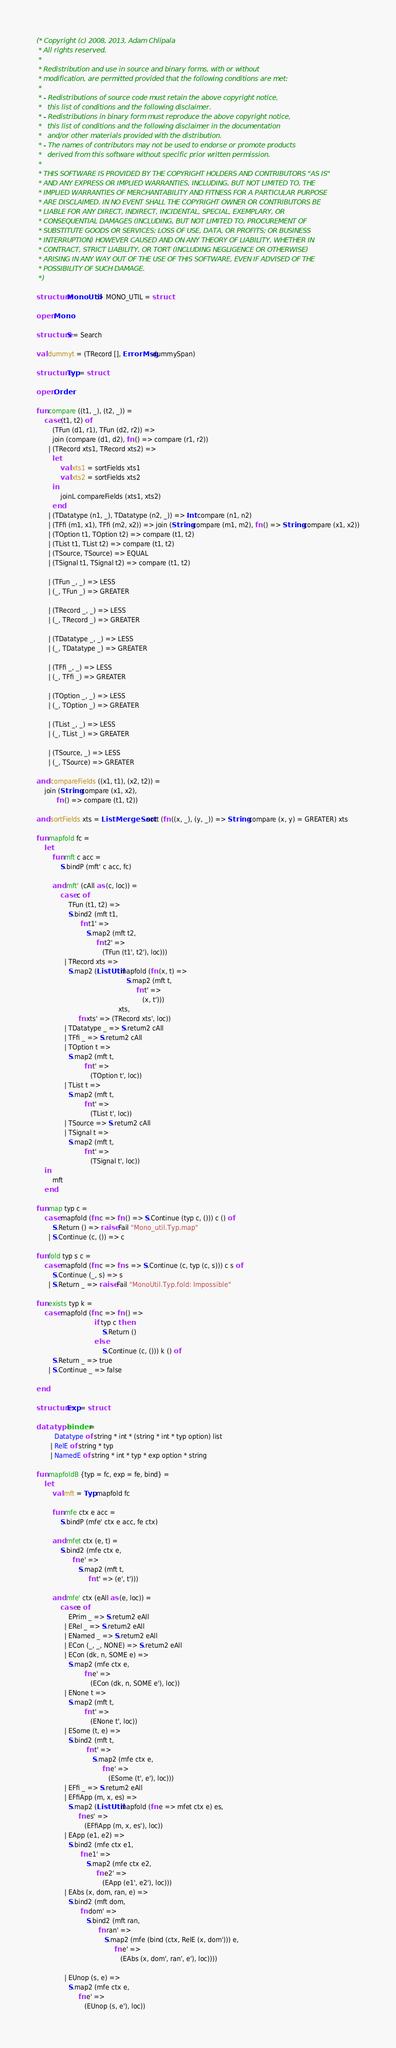Convert code to text. <code><loc_0><loc_0><loc_500><loc_500><_SML_>(* Copyright (c) 2008, 2013, Adam Chlipala
 * All rights reserved.
 *
 * Redistribution and use in source and binary forms, with or without
 * modification, are permitted provided that the following conditions are met:
 *
 * - Redistributions of source code must retain the above copyright notice,
 *   this list of conditions and the following disclaimer.
 * - Redistributions in binary form must reproduce the above copyright notice,
 *   this list of conditions and the following disclaimer in the documentation
 *   and/or other materials provided with the distribution.
 * - The names of contributors may not be used to endorse or promote products
 *   derived from this software without specific prior written permission.
 *
 * THIS SOFTWARE IS PROVIDED BY THE COPYRIGHT HOLDERS AND CONTRIBUTORS "AS IS"
 * AND ANY EXPRESS OR IMPLIED WARRANTIES, INCLUDING, BUT NOT LIMITED TO, THE
 * IMPLIED WARRANTIES OF MERCHANTABILITY AND FITNESS FOR A PARTICULAR PURPOSE
 * ARE DISCLAIMED. IN NO EVENT SHALL THE COPYRIGHT OWNER OR CONTRIBUTORS BE
 * LIABLE FOR ANY DIRECT, INDIRECT, INCIDENTAL, SPECIAL, EXEMPLARY, OR
 * CONSEQUENTIAL DAMAGES (INCLUDING, BUT NOT LIMITED TO, PROCUREMENT OF
 * SUBSTITUTE GOODS OR SERVICES; LOSS OF USE, DATA, OR PROFITS; OR BUSINESS
 * INTERRUPTION) HOWEVER CAUSED AND ON ANY THEORY OF LIABILITY, WHETHER IN
 * CONTRACT, STRICT LIABILITY, OR TORT (INCLUDING NEGLIGENCE OR OTHERWISE)
 * ARISING IN ANY WAY OUT OF THE USE OF THIS SOFTWARE, EVEN IF ADVISED OF THE
 * POSSIBILITY OF SUCH DAMAGE.
 *)

structure MonoUtil :> MONO_UTIL = struct

open Mono

structure S = Search

val dummyt = (TRecord [], ErrorMsg.dummySpan)

structure Typ = struct

open Order

fun compare ((t1, _), (t2, _)) =
    case (t1, t2) of
        (TFun (d1, r1), TFun (d2, r2)) =>
        join (compare (d1, d2), fn () => compare (r1, r2))
      | (TRecord xts1, TRecord xts2) =>
        let
            val xts1 = sortFields xts1
            val xts2 = sortFields xts2
        in
            joinL compareFields (xts1, xts2)
        end
      | (TDatatype (n1, _), TDatatype (n2, _)) => Int.compare (n1, n2)
      | (TFfi (m1, x1), TFfi (m2, x2)) => join (String.compare (m1, m2), fn () => String.compare (x1, x2))
      | (TOption t1, TOption t2) => compare (t1, t2)
      | (TList t1, TList t2) => compare (t1, t2)
      | (TSource, TSource) => EQUAL
      | (TSignal t1, TSignal t2) => compare (t1, t2)

      | (TFun _, _) => LESS
      | (_, TFun _) => GREATER

      | (TRecord _, _) => LESS
      | (_, TRecord _) => GREATER

      | (TDatatype _, _) => LESS
      | (_, TDatatype _) => GREATER

      | (TFfi _, _) => LESS
      | (_, TFfi _) => GREATER

      | (TOption _, _) => LESS
      | (_, TOption _) => GREATER

      | (TList _, _) => LESS
      | (_, TList _) => GREATER

      | (TSource, _) => LESS
      | (_, TSource) => GREATER

and compareFields ((x1, t1), (x2, t2)) =
    join (String.compare (x1, x2),
          fn () => compare (t1, t2))

and sortFields xts = ListMergeSort.sort (fn ((x, _), (y, _)) => String.compare (x, y) = GREATER) xts

fun mapfold fc =
    let
        fun mft c acc =
            S.bindP (mft' c acc, fc)

        and mft' (cAll as (c, loc)) =
            case c of
                TFun (t1, t2) =>
                S.bind2 (mft t1,
                      fn t1' =>
                         S.map2 (mft t2,
                              fn t2' =>
                                 (TFun (t1', t2'), loc)))
              | TRecord xts =>
                S.map2 (ListUtil.mapfold (fn (x, t) =>
                                             S.map2 (mft t,
                                                  fn t' =>
                                                     (x, t')))
                                         xts,
                     fn xts' => (TRecord xts', loc))
              | TDatatype _ => S.return2 cAll
              | TFfi _ => S.return2 cAll
              | TOption t =>
                S.map2 (mft t,
                        fn t' =>
                           (TOption t', loc))
              | TList t =>
                S.map2 (mft t,
                        fn t' =>
                           (TList t', loc))
              | TSource => S.return2 cAll
              | TSignal t =>
                S.map2 (mft t,
                        fn t' =>
                           (TSignal t', loc))
    in
        mft
    end

fun map typ c =
    case mapfold (fn c => fn () => S.Continue (typ c, ())) c () of
        S.Return () => raise Fail "Mono_util.Typ.map"
      | S.Continue (c, ()) => c

fun fold typ s c =
    case mapfold (fn c => fn s => S.Continue (c, typ (c, s))) c s of
        S.Continue (_, s) => s
      | S.Return _ => raise Fail "MonoUtil.Typ.fold: Impossible"

fun exists typ k =
    case mapfold (fn c => fn () =>
                             if typ c then
                                 S.Return ()
                             else
                                 S.Continue (c, ())) k () of
        S.Return _ => true
      | S.Continue _ => false

end

structure Exp = struct

datatype binder =
         Datatype of string * int * (string * int * typ option) list
       | RelE of string * typ
       | NamedE of string * int * typ * exp option * string

fun mapfoldB {typ = fc, exp = fe, bind} =
    let
        val mft = Typ.mapfold fc

        fun mfe ctx e acc =
            S.bindP (mfe' ctx e acc, fe ctx)

        and mfet ctx (e, t) =
            S.bind2 (mfe ctx e,
                  fn e' =>
                     S.map2 (mft t,
                          fn t' => (e', t')))

        and mfe' ctx (eAll as (e, loc)) =
            case e of
                EPrim _ => S.return2 eAll
              | ERel _ => S.return2 eAll
              | ENamed _ => S.return2 eAll
              | ECon (_, _, NONE) => S.return2 eAll
              | ECon (dk, n, SOME e) =>
                S.map2 (mfe ctx e,
                        fn e' =>
                           (ECon (dk, n, SOME e'), loc))
              | ENone t =>
                S.map2 (mft t,
                        fn t' =>
                           (ENone t', loc))
              | ESome (t, e) =>
                S.bind2 (mft t,
                         fn t' =>
                            S.map2 (mfe ctx e,
                                 fn e' =>
                                    (ESome (t', e'), loc)))
              | EFfi _ => S.return2 eAll
              | EFfiApp (m, x, es) =>
                S.map2 (ListUtil.mapfold (fn e => mfet ctx e) es,
                     fn es' =>
                        (EFfiApp (m, x, es'), loc))
              | EApp (e1, e2) =>
                S.bind2 (mfe ctx e1,
                      fn e1' =>
                         S.map2 (mfe ctx e2,
                              fn e2' =>
                                 (EApp (e1', e2'), loc)))
              | EAbs (x, dom, ran, e) =>
                S.bind2 (mft dom,
                      fn dom' =>
                         S.bind2 (mft ran,
                               fn ran' =>
                                  S.map2 (mfe (bind (ctx, RelE (x, dom'))) e,
                                       fn e' =>
                                          (EAbs (x, dom', ran', e'), loc))))

              | EUnop (s, e) =>
                S.map2 (mfe ctx e,
                     fn e' =>
                        (EUnop (s, e'), loc))</code> 